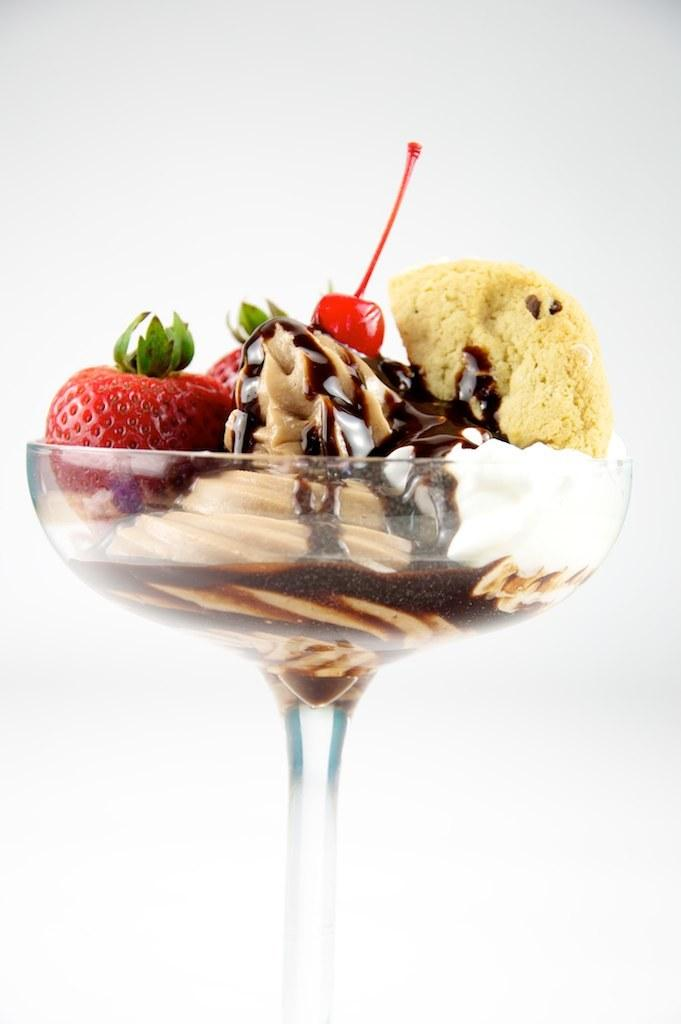What type of dessert is present in the image? There is ice cream in the image. What fruit can be seen on top of the ice cream? There is strawberry and cherry in the image. What other food items are present in the image? There are other food items in a cup in the image. What color is the background of the image? The background of the image is white in color. What is the income of the person who owns the car in the image? There is no car present in the image, so it is not possible to determine the income of the owner. 